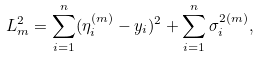Convert formula to latex. <formula><loc_0><loc_0><loc_500><loc_500>L _ { m } ^ { 2 } = \sum _ { i = 1 } ^ { n } ( \eta _ { i } ^ { ( m ) } - y _ { i } ) ^ { 2 } + \sum _ { i = 1 } ^ { n } \sigma _ { i } ^ { 2 ( m ) } ,</formula> 